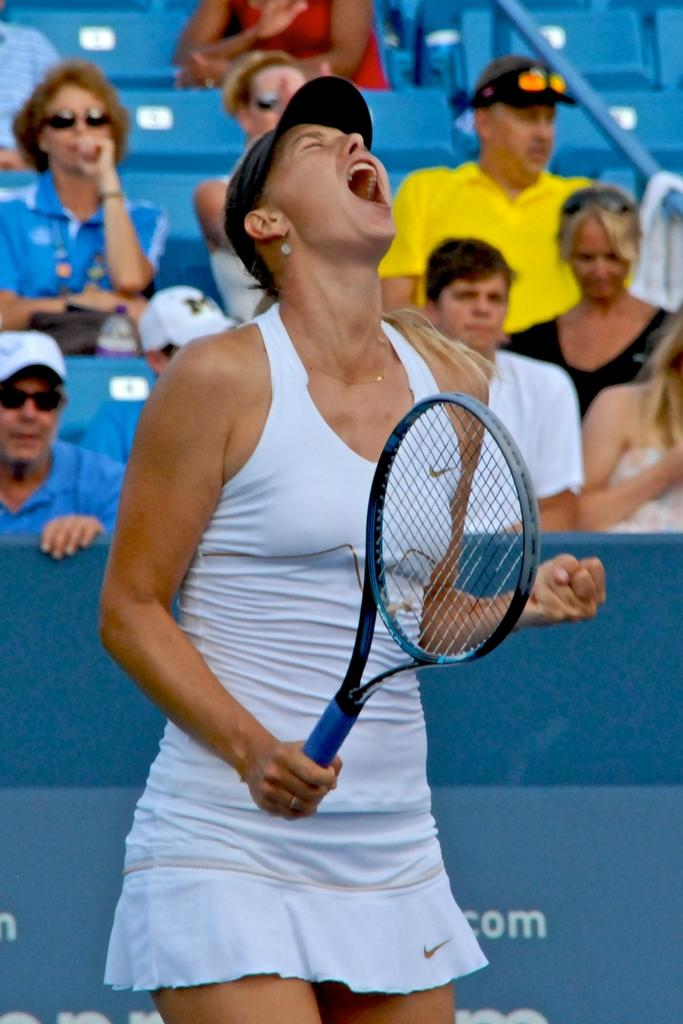Who is the main subject in the image? There is a woman in the image. What is the woman holding in the image? The woman is holding a tennis racket. Can you describe the people behind the woman? There are people sitting behind the woman. What type of rabbit can be seen causing trouble in the image? There is no rabbit present in the image, and therefore no such activity can be observed. What color is the chalk used to draw on the tennis court in the image? There is no chalk or tennis court present in the image. 